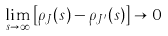Convert formula to latex. <formula><loc_0><loc_0><loc_500><loc_500>\lim _ { s \rightarrow \infty } \left [ \rho _ { J } ( s ) - \rho _ { J ^ { \prime } } ( s ) \right ] \rightarrow 0</formula> 